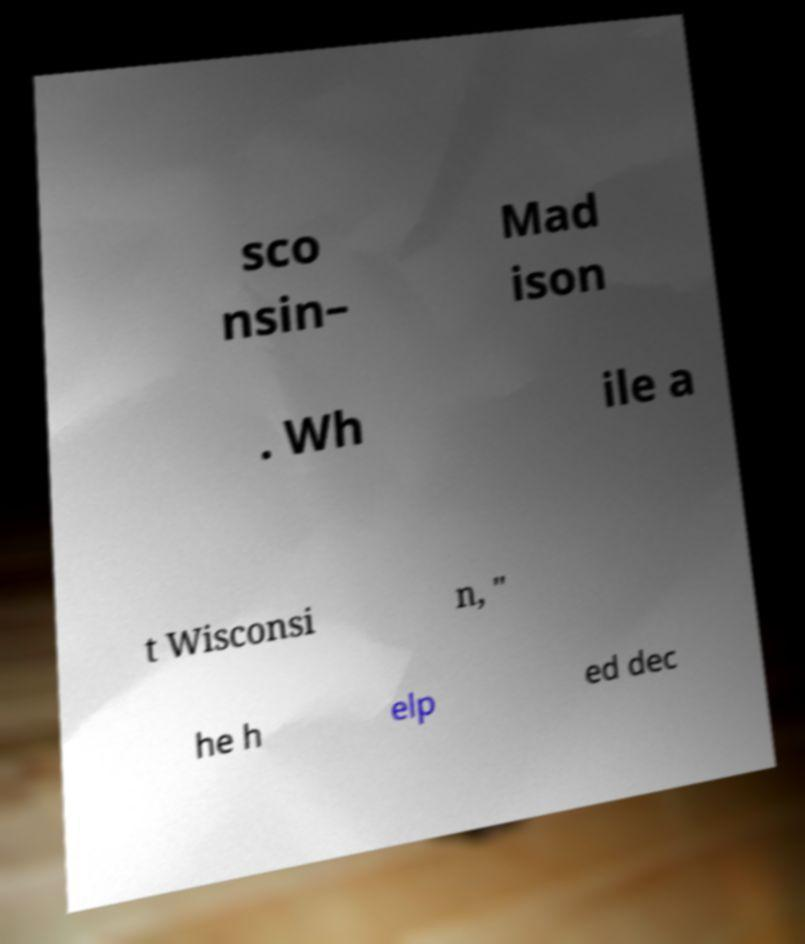What messages or text are displayed in this image? I need them in a readable, typed format. sco nsin– Mad ison . Wh ile a t Wisconsi n, " he h elp ed dec 